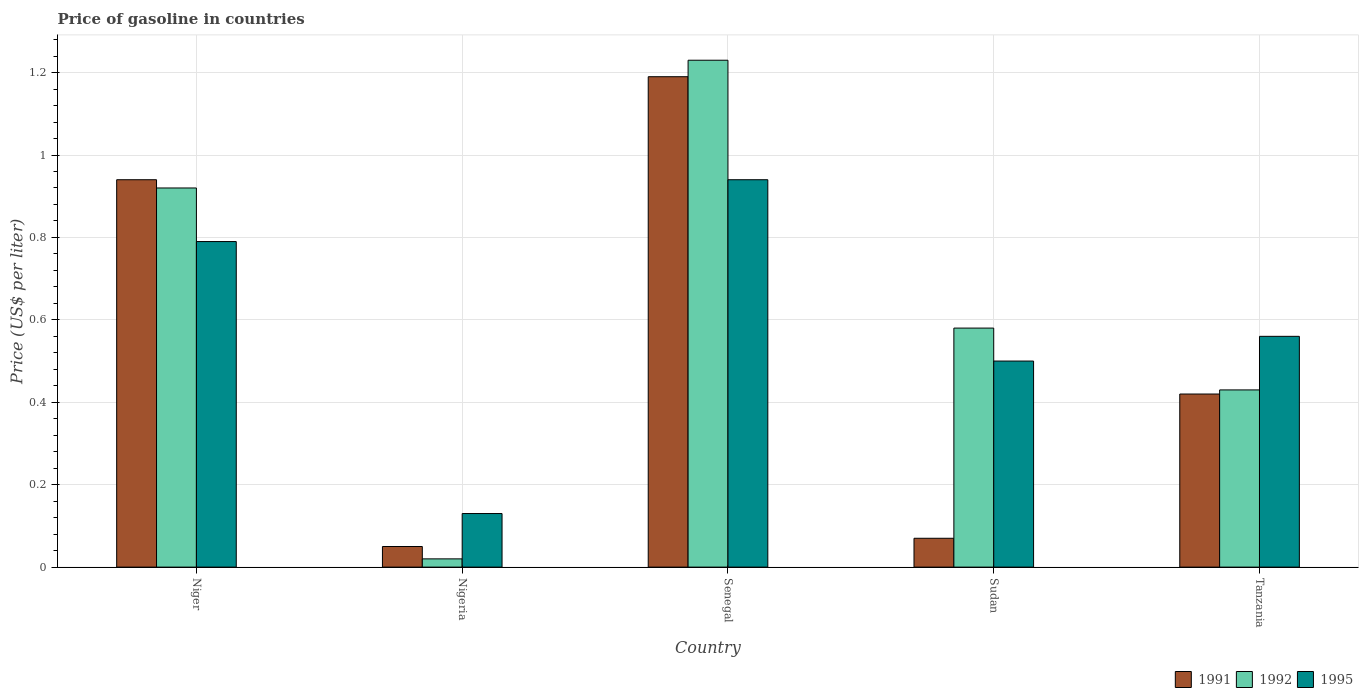How many groups of bars are there?
Offer a very short reply. 5. Are the number of bars per tick equal to the number of legend labels?
Keep it short and to the point. Yes. How many bars are there on the 3rd tick from the right?
Offer a terse response. 3. What is the label of the 1st group of bars from the left?
Provide a succinct answer. Niger. In how many cases, is the number of bars for a given country not equal to the number of legend labels?
Ensure brevity in your answer.  0. What is the price of gasoline in 1991 in Tanzania?
Offer a very short reply. 0.42. Across all countries, what is the maximum price of gasoline in 1992?
Provide a short and direct response. 1.23. Across all countries, what is the minimum price of gasoline in 1995?
Offer a terse response. 0.13. In which country was the price of gasoline in 1991 maximum?
Give a very brief answer. Senegal. In which country was the price of gasoline in 1992 minimum?
Ensure brevity in your answer.  Nigeria. What is the total price of gasoline in 1995 in the graph?
Your response must be concise. 2.92. What is the difference between the price of gasoline in 1992 in Nigeria and that in Tanzania?
Your answer should be very brief. -0.41. What is the difference between the price of gasoline in 1995 in Niger and the price of gasoline in 1991 in Sudan?
Keep it short and to the point. 0.72. What is the average price of gasoline in 1992 per country?
Keep it short and to the point. 0.64. What is the difference between the price of gasoline of/in 1995 and price of gasoline of/in 1991 in Niger?
Your answer should be compact. -0.15. In how many countries, is the price of gasoline in 1992 greater than 0.12 US$?
Make the answer very short. 4. What is the ratio of the price of gasoline in 1991 in Sudan to that in Tanzania?
Your response must be concise. 0.17. Is the difference between the price of gasoline in 1995 in Nigeria and Senegal greater than the difference between the price of gasoline in 1991 in Nigeria and Senegal?
Your answer should be compact. Yes. What is the difference between the highest and the second highest price of gasoline in 1995?
Your answer should be compact. 0.15. What is the difference between the highest and the lowest price of gasoline in 1995?
Keep it short and to the point. 0.81. Is the sum of the price of gasoline in 1991 in Nigeria and Senegal greater than the maximum price of gasoline in 1992 across all countries?
Your answer should be very brief. Yes. How many bars are there?
Offer a terse response. 15. Are all the bars in the graph horizontal?
Keep it short and to the point. No. What is the difference between two consecutive major ticks on the Y-axis?
Your answer should be compact. 0.2. Are the values on the major ticks of Y-axis written in scientific E-notation?
Give a very brief answer. No. How many legend labels are there?
Provide a short and direct response. 3. What is the title of the graph?
Your response must be concise. Price of gasoline in countries. What is the label or title of the Y-axis?
Your response must be concise. Price (US$ per liter). What is the Price (US$ per liter) of 1991 in Niger?
Offer a terse response. 0.94. What is the Price (US$ per liter) in 1992 in Niger?
Your answer should be very brief. 0.92. What is the Price (US$ per liter) in 1995 in Niger?
Provide a short and direct response. 0.79. What is the Price (US$ per liter) of 1995 in Nigeria?
Offer a terse response. 0.13. What is the Price (US$ per liter) of 1991 in Senegal?
Provide a succinct answer. 1.19. What is the Price (US$ per liter) of 1992 in Senegal?
Give a very brief answer. 1.23. What is the Price (US$ per liter) in 1995 in Senegal?
Ensure brevity in your answer.  0.94. What is the Price (US$ per liter) in 1991 in Sudan?
Provide a succinct answer. 0.07. What is the Price (US$ per liter) of 1992 in Sudan?
Provide a succinct answer. 0.58. What is the Price (US$ per liter) in 1991 in Tanzania?
Give a very brief answer. 0.42. What is the Price (US$ per liter) of 1992 in Tanzania?
Make the answer very short. 0.43. What is the Price (US$ per liter) in 1995 in Tanzania?
Provide a succinct answer. 0.56. Across all countries, what is the maximum Price (US$ per liter) in 1991?
Make the answer very short. 1.19. Across all countries, what is the maximum Price (US$ per liter) of 1992?
Provide a succinct answer. 1.23. Across all countries, what is the minimum Price (US$ per liter) in 1995?
Your answer should be compact. 0.13. What is the total Price (US$ per liter) in 1991 in the graph?
Provide a short and direct response. 2.67. What is the total Price (US$ per liter) in 1992 in the graph?
Your answer should be compact. 3.18. What is the total Price (US$ per liter) of 1995 in the graph?
Your response must be concise. 2.92. What is the difference between the Price (US$ per liter) of 1991 in Niger and that in Nigeria?
Offer a very short reply. 0.89. What is the difference between the Price (US$ per liter) of 1995 in Niger and that in Nigeria?
Your answer should be compact. 0.66. What is the difference between the Price (US$ per liter) of 1991 in Niger and that in Senegal?
Your answer should be compact. -0.25. What is the difference between the Price (US$ per liter) in 1992 in Niger and that in Senegal?
Offer a terse response. -0.31. What is the difference between the Price (US$ per liter) of 1995 in Niger and that in Senegal?
Provide a short and direct response. -0.15. What is the difference between the Price (US$ per liter) of 1991 in Niger and that in Sudan?
Provide a succinct answer. 0.87. What is the difference between the Price (US$ per liter) of 1992 in Niger and that in Sudan?
Offer a terse response. 0.34. What is the difference between the Price (US$ per liter) of 1995 in Niger and that in Sudan?
Provide a succinct answer. 0.29. What is the difference between the Price (US$ per liter) of 1991 in Niger and that in Tanzania?
Your response must be concise. 0.52. What is the difference between the Price (US$ per liter) of 1992 in Niger and that in Tanzania?
Your answer should be compact. 0.49. What is the difference between the Price (US$ per liter) of 1995 in Niger and that in Tanzania?
Provide a succinct answer. 0.23. What is the difference between the Price (US$ per liter) in 1991 in Nigeria and that in Senegal?
Provide a succinct answer. -1.14. What is the difference between the Price (US$ per liter) of 1992 in Nigeria and that in Senegal?
Ensure brevity in your answer.  -1.21. What is the difference between the Price (US$ per liter) of 1995 in Nigeria and that in Senegal?
Offer a very short reply. -0.81. What is the difference between the Price (US$ per liter) of 1991 in Nigeria and that in Sudan?
Your answer should be compact. -0.02. What is the difference between the Price (US$ per liter) in 1992 in Nigeria and that in Sudan?
Your answer should be compact. -0.56. What is the difference between the Price (US$ per liter) in 1995 in Nigeria and that in Sudan?
Ensure brevity in your answer.  -0.37. What is the difference between the Price (US$ per liter) in 1991 in Nigeria and that in Tanzania?
Provide a short and direct response. -0.37. What is the difference between the Price (US$ per liter) in 1992 in Nigeria and that in Tanzania?
Offer a terse response. -0.41. What is the difference between the Price (US$ per liter) of 1995 in Nigeria and that in Tanzania?
Ensure brevity in your answer.  -0.43. What is the difference between the Price (US$ per liter) in 1991 in Senegal and that in Sudan?
Offer a terse response. 1.12. What is the difference between the Price (US$ per liter) in 1992 in Senegal and that in Sudan?
Your response must be concise. 0.65. What is the difference between the Price (US$ per liter) of 1995 in Senegal and that in Sudan?
Make the answer very short. 0.44. What is the difference between the Price (US$ per liter) in 1991 in Senegal and that in Tanzania?
Your answer should be compact. 0.77. What is the difference between the Price (US$ per liter) in 1992 in Senegal and that in Tanzania?
Make the answer very short. 0.8. What is the difference between the Price (US$ per liter) of 1995 in Senegal and that in Tanzania?
Make the answer very short. 0.38. What is the difference between the Price (US$ per liter) of 1991 in Sudan and that in Tanzania?
Provide a succinct answer. -0.35. What is the difference between the Price (US$ per liter) of 1992 in Sudan and that in Tanzania?
Provide a short and direct response. 0.15. What is the difference between the Price (US$ per liter) in 1995 in Sudan and that in Tanzania?
Give a very brief answer. -0.06. What is the difference between the Price (US$ per liter) of 1991 in Niger and the Price (US$ per liter) of 1992 in Nigeria?
Make the answer very short. 0.92. What is the difference between the Price (US$ per liter) in 1991 in Niger and the Price (US$ per liter) in 1995 in Nigeria?
Keep it short and to the point. 0.81. What is the difference between the Price (US$ per liter) in 1992 in Niger and the Price (US$ per liter) in 1995 in Nigeria?
Offer a very short reply. 0.79. What is the difference between the Price (US$ per liter) of 1991 in Niger and the Price (US$ per liter) of 1992 in Senegal?
Your answer should be very brief. -0.29. What is the difference between the Price (US$ per liter) of 1992 in Niger and the Price (US$ per liter) of 1995 in Senegal?
Make the answer very short. -0.02. What is the difference between the Price (US$ per liter) of 1991 in Niger and the Price (US$ per liter) of 1992 in Sudan?
Offer a terse response. 0.36. What is the difference between the Price (US$ per liter) of 1991 in Niger and the Price (US$ per liter) of 1995 in Sudan?
Provide a succinct answer. 0.44. What is the difference between the Price (US$ per liter) in 1992 in Niger and the Price (US$ per liter) in 1995 in Sudan?
Your answer should be compact. 0.42. What is the difference between the Price (US$ per liter) in 1991 in Niger and the Price (US$ per liter) in 1992 in Tanzania?
Provide a short and direct response. 0.51. What is the difference between the Price (US$ per liter) in 1991 in Niger and the Price (US$ per liter) in 1995 in Tanzania?
Give a very brief answer. 0.38. What is the difference between the Price (US$ per liter) of 1992 in Niger and the Price (US$ per liter) of 1995 in Tanzania?
Offer a very short reply. 0.36. What is the difference between the Price (US$ per liter) of 1991 in Nigeria and the Price (US$ per liter) of 1992 in Senegal?
Ensure brevity in your answer.  -1.18. What is the difference between the Price (US$ per liter) of 1991 in Nigeria and the Price (US$ per liter) of 1995 in Senegal?
Provide a short and direct response. -0.89. What is the difference between the Price (US$ per liter) in 1992 in Nigeria and the Price (US$ per liter) in 1995 in Senegal?
Give a very brief answer. -0.92. What is the difference between the Price (US$ per liter) of 1991 in Nigeria and the Price (US$ per liter) of 1992 in Sudan?
Keep it short and to the point. -0.53. What is the difference between the Price (US$ per liter) of 1991 in Nigeria and the Price (US$ per liter) of 1995 in Sudan?
Offer a very short reply. -0.45. What is the difference between the Price (US$ per liter) of 1992 in Nigeria and the Price (US$ per liter) of 1995 in Sudan?
Ensure brevity in your answer.  -0.48. What is the difference between the Price (US$ per liter) in 1991 in Nigeria and the Price (US$ per liter) in 1992 in Tanzania?
Provide a succinct answer. -0.38. What is the difference between the Price (US$ per liter) in 1991 in Nigeria and the Price (US$ per liter) in 1995 in Tanzania?
Ensure brevity in your answer.  -0.51. What is the difference between the Price (US$ per liter) in 1992 in Nigeria and the Price (US$ per liter) in 1995 in Tanzania?
Provide a short and direct response. -0.54. What is the difference between the Price (US$ per liter) in 1991 in Senegal and the Price (US$ per liter) in 1992 in Sudan?
Give a very brief answer. 0.61. What is the difference between the Price (US$ per liter) of 1991 in Senegal and the Price (US$ per liter) of 1995 in Sudan?
Ensure brevity in your answer.  0.69. What is the difference between the Price (US$ per liter) in 1992 in Senegal and the Price (US$ per liter) in 1995 in Sudan?
Keep it short and to the point. 0.73. What is the difference between the Price (US$ per liter) of 1991 in Senegal and the Price (US$ per liter) of 1992 in Tanzania?
Keep it short and to the point. 0.76. What is the difference between the Price (US$ per liter) in 1991 in Senegal and the Price (US$ per liter) in 1995 in Tanzania?
Keep it short and to the point. 0.63. What is the difference between the Price (US$ per liter) of 1992 in Senegal and the Price (US$ per liter) of 1995 in Tanzania?
Provide a succinct answer. 0.67. What is the difference between the Price (US$ per liter) in 1991 in Sudan and the Price (US$ per liter) in 1992 in Tanzania?
Ensure brevity in your answer.  -0.36. What is the difference between the Price (US$ per liter) of 1991 in Sudan and the Price (US$ per liter) of 1995 in Tanzania?
Keep it short and to the point. -0.49. What is the average Price (US$ per liter) in 1991 per country?
Your answer should be very brief. 0.53. What is the average Price (US$ per liter) of 1992 per country?
Keep it short and to the point. 0.64. What is the average Price (US$ per liter) in 1995 per country?
Ensure brevity in your answer.  0.58. What is the difference between the Price (US$ per liter) of 1991 and Price (US$ per liter) of 1992 in Niger?
Ensure brevity in your answer.  0.02. What is the difference between the Price (US$ per liter) of 1991 and Price (US$ per liter) of 1995 in Niger?
Offer a very short reply. 0.15. What is the difference between the Price (US$ per liter) in 1992 and Price (US$ per liter) in 1995 in Niger?
Make the answer very short. 0.13. What is the difference between the Price (US$ per liter) in 1991 and Price (US$ per liter) in 1992 in Nigeria?
Offer a terse response. 0.03. What is the difference between the Price (US$ per liter) in 1991 and Price (US$ per liter) in 1995 in Nigeria?
Make the answer very short. -0.08. What is the difference between the Price (US$ per liter) of 1992 and Price (US$ per liter) of 1995 in Nigeria?
Make the answer very short. -0.11. What is the difference between the Price (US$ per liter) of 1991 and Price (US$ per liter) of 1992 in Senegal?
Ensure brevity in your answer.  -0.04. What is the difference between the Price (US$ per liter) of 1991 and Price (US$ per liter) of 1995 in Senegal?
Give a very brief answer. 0.25. What is the difference between the Price (US$ per liter) of 1992 and Price (US$ per liter) of 1995 in Senegal?
Your response must be concise. 0.29. What is the difference between the Price (US$ per liter) in 1991 and Price (US$ per liter) in 1992 in Sudan?
Keep it short and to the point. -0.51. What is the difference between the Price (US$ per liter) in 1991 and Price (US$ per liter) in 1995 in Sudan?
Give a very brief answer. -0.43. What is the difference between the Price (US$ per liter) in 1992 and Price (US$ per liter) in 1995 in Sudan?
Give a very brief answer. 0.08. What is the difference between the Price (US$ per liter) in 1991 and Price (US$ per liter) in 1992 in Tanzania?
Ensure brevity in your answer.  -0.01. What is the difference between the Price (US$ per liter) of 1991 and Price (US$ per liter) of 1995 in Tanzania?
Offer a terse response. -0.14. What is the difference between the Price (US$ per liter) in 1992 and Price (US$ per liter) in 1995 in Tanzania?
Give a very brief answer. -0.13. What is the ratio of the Price (US$ per liter) of 1992 in Niger to that in Nigeria?
Your answer should be compact. 46. What is the ratio of the Price (US$ per liter) in 1995 in Niger to that in Nigeria?
Your answer should be very brief. 6.08. What is the ratio of the Price (US$ per liter) in 1991 in Niger to that in Senegal?
Make the answer very short. 0.79. What is the ratio of the Price (US$ per liter) of 1992 in Niger to that in Senegal?
Your response must be concise. 0.75. What is the ratio of the Price (US$ per liter) of 1995 in Niger to that in Senegal?
Keep it short and to the point. 0.84. What is the ratio of the Price (US$ per liter) of 1991 in Niger to that in Sudan?
Your answer should be very brief. 13.43. What is the ratio of the Price (US$ per liter) of 1992 in Niger to that in Sudan?
Ensure brevity in your answer.  1.59. What is the ratio of the Price (US$ per liter) of 1995 in Niger to that in Sudan?
Make the answer very short. 1.58. What is the ratio of the Price (US$ per liter) of 1991 in Niger to that in Tanzania?
Your response must be concise. 2.24. What is the ratio of the Price (US$ per liter) in 1992 in Niger to that in Tanzania?
Your response must be concise. 2.14. What is the ratio of the Price (US$ per liter) in 1995 in Niger to that in Tanzania?
Make the answer very short. 1.41. What is the ratio of the Price (US$ per liter) of 1991 in Nigeria to that in Senegal?
Make the answer very short. 0.04. What is the ratio of the Price (US$ per liter) in 1992 in Nigeria to that in Senegal?
Provide a short and direct response. 0.02. What is the ratio of the Price (US$ per liter) in 1995 in Nigeria to that in Senegal?
Your response must be concise. 0.14. What is the ratio of the Price (US$ per liter) of 1991 in Nigeria to that in Sudan?
Keep it short and to the point. 0.71. What is the ratio of the Price (US$ per liter) of 1992 in Nigeria to that in Sudan?
Offer a terse response. 0.03. What is the ratio of the Price (US$ per liter) of 1995 in Nigeria to that in Sudan?
Give a very brief answer. 0.26. What is the ratio of the Price (US$ per liter) of 1991 in Nigeria to that in Tanzania?
Your answer should be compact. 0.12. What is the ratio of the Price (US$ per liter) in 1992 in Nigeria to that in Tanzania?
Your answer should be compact. 0.05. What is the ratio of the Price (US$ per liter) in 1995 in Nigeria to that in Tanzania?
Your answer should be very brief. 0.23. What is the ratio of the Price (US$ per liter) in 1991 in Senegal to that in Sudan?
Your response must be concise. 17. What is the ratio of the Price (US$ per liter) of 1992 in Senegal to that in Sudan?
Ensure brevity in your answer.  2.12. What is the ratio of the Price (US$ per liter) of 1995 in Senegal to that in Sudan?
Your answer should be very brief. 1.88. What is the ratio of the Price (US$ per liter) in 1991 in Senegal to that in Tanzania?
Make the answer very short. 2.83. What is the ratio of the Price (US$ per liter) of 1992 in Senegal to that in Tanzania?
Your answer should be compact. 2.86. What is the ratio of the Price (US$ per liter) of 1995 in Senegal to that in Tanzania?
Keep it short and to the point. 1.68. What is the ratio of the Price (US$ per liter) of 1992 in Sudan to that in Tanzania?
Ensure brevity in your answer.  1.35. What is the ratio of the Price (US$ per liter) of 1995 in Sudan to that in Tanzania?
Provide a succinct answer. 0.89. What is the difference between the highest and the second highest Price (US$ per liter) of 1991?
Your response must be concise. 0.25. What is the difference between the highest and the second highest Price (US$ per liter) of 1992?
Give a very brief answer. 0.31. What is the difference between the highest and the lowest Price (US$ per liter) of 1991?
Give a very brief answer. 1.14. What is the difference between the highest and the lowest Price (US$ per liter) of 1992?
Provide a succinct answer. 1.21. What is the difference between the highest and the lowest Price (US$ per liter) in 1995?
Your answer should be very brief. 0.81. 